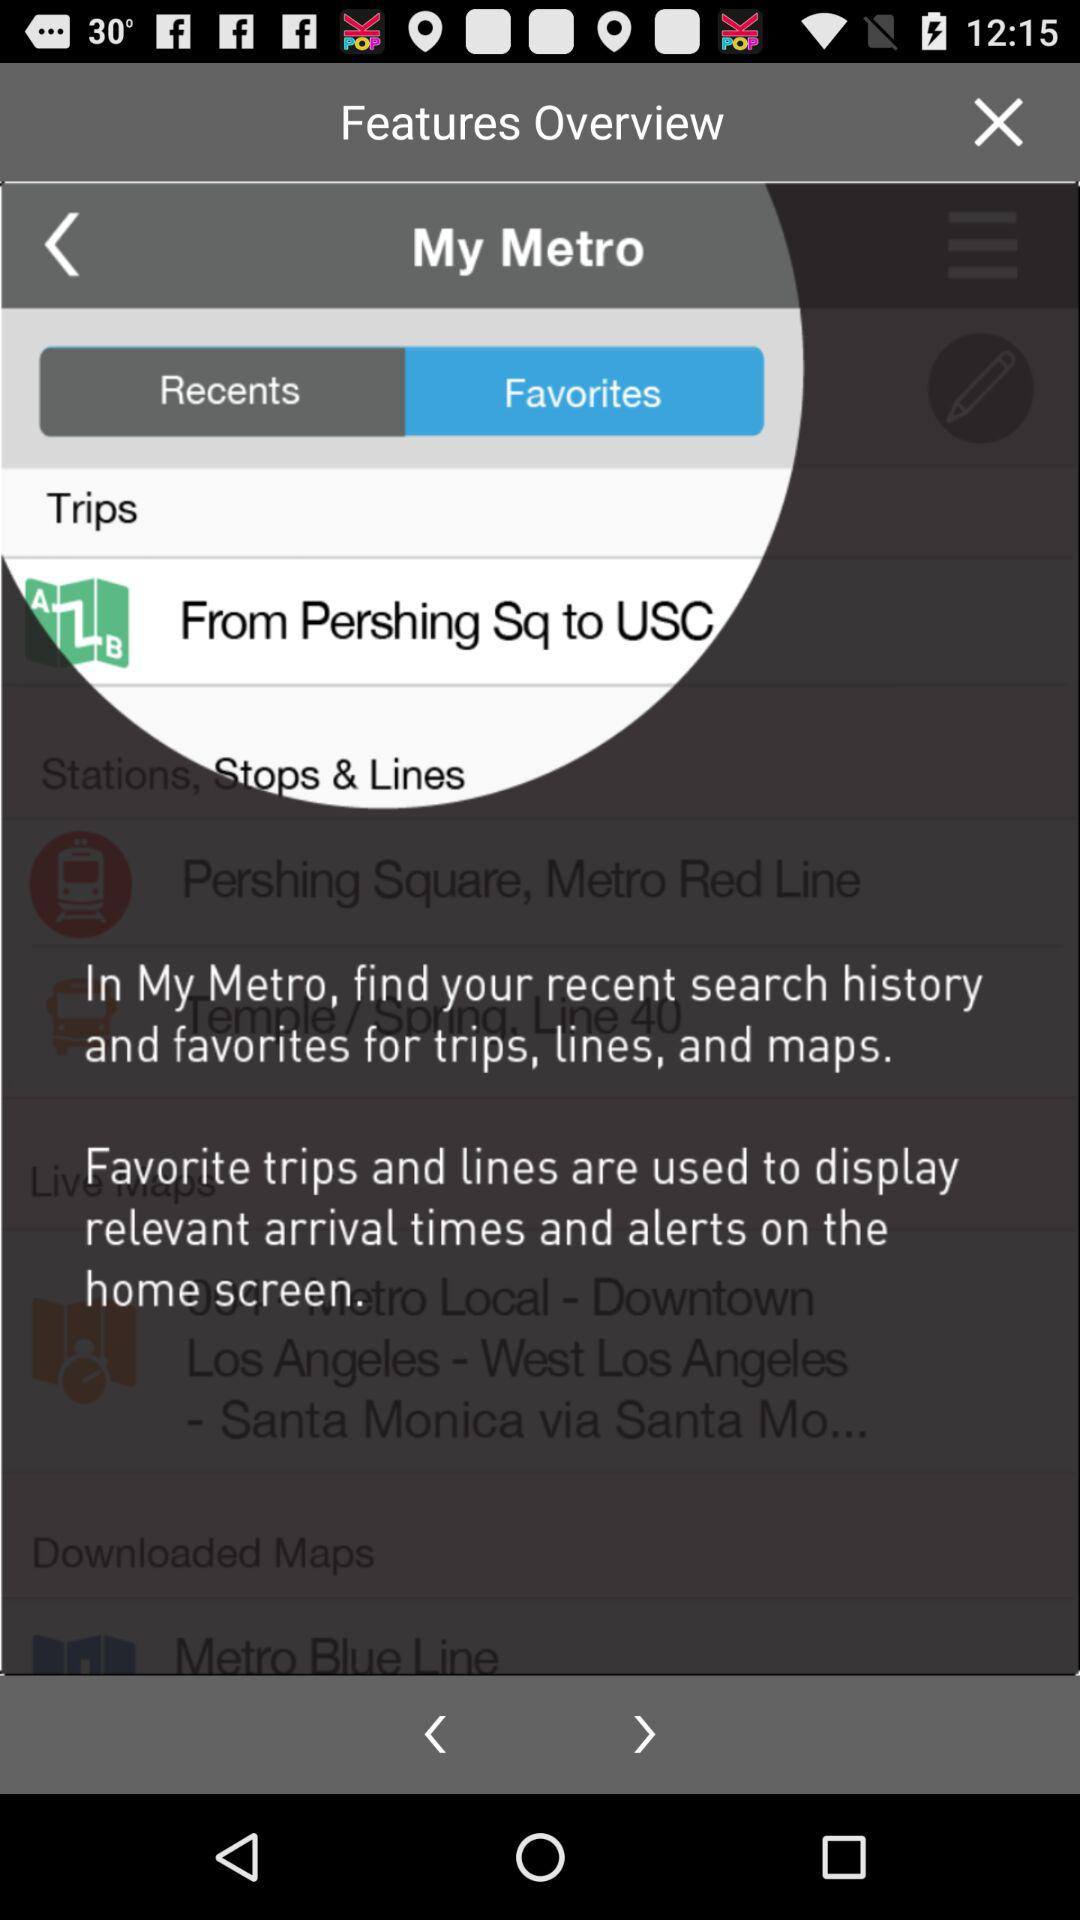What is the name of the application? The name of the application is "My Metro". 